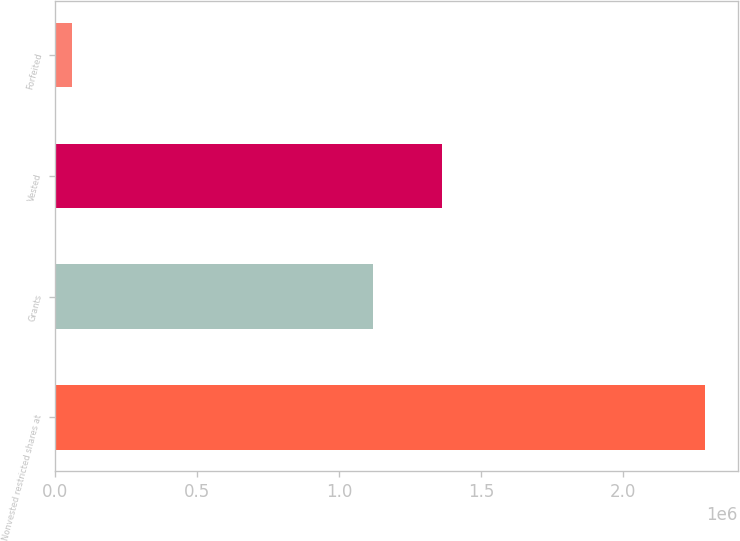Convert chart to OTSL. <chart><loc_0><loc_0><loc_500><loc_500><bar_chart><fcel>Nonvested restricted shares at<fcel>Grants<fcel>Vested<fcel>Forfeited<nl><fcel>2.28913e+06<fcel>1.11936e+06<fcel>1.36074e+06<fcel>58253<nl></chart> 